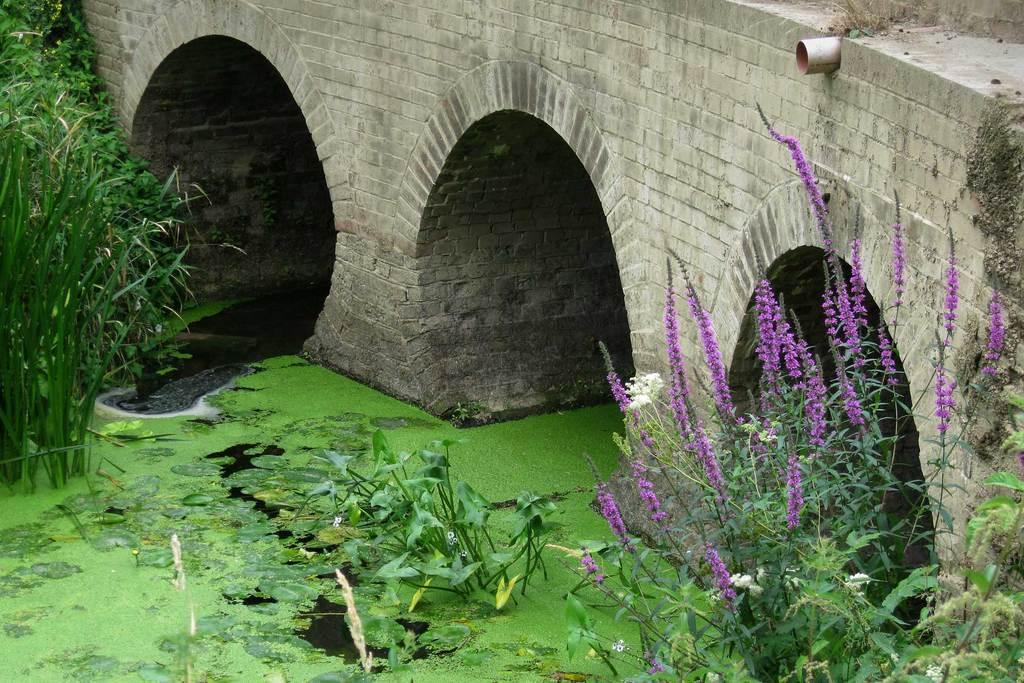What is at the bottom of the image? There is water at the bottom of the image. What can be seen on the water's surface? Green algae is present on the water. What type of vegetation is visible in the image? There are plants along with flowers in the image. What structure is located at the top of the image? There is a bridge at the top of the image. What type of food is being prepared by the laborer in the image? There is no laborer or food preparation visible in the image. How many points are present in the image? There are no points present in the image. 